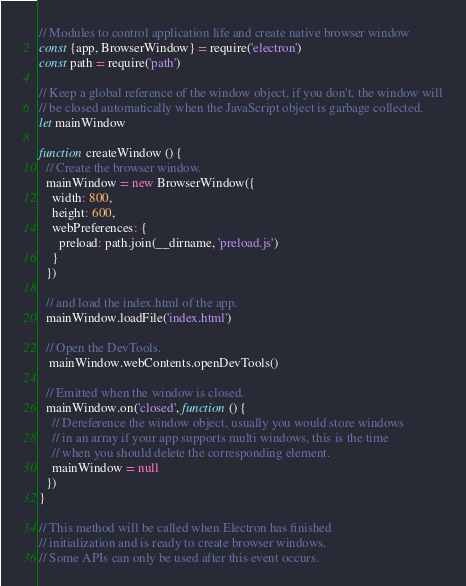<code> <loc_0><loc_0><loc_500><loc_500><_JavaScript_>// Modules to control application life and create native browser window
const {app, BrowserWindow} = require('electron')
const path = require('path')

// Keep a global reference of the window object, if you don't, the window will
// be closed automatically when the JavaScript object is garbage collected.
let mainWindow

function createWindow () {
  // Create the browser window.
  mainWindow = new BrowserWindow({
    width: 800,
    height: 600,
    webPreferences: {
      preload: path.join(__dirname, 'preload.js')
    }
  })

  // and load the index.html of the app.
  mainWindow.loadFile('index.html')

  // Open the DevTools.
   mainWindow.webContents.openDevTools()

  // Emitted when the window is closed.
  mainWindow.on('closed', function () {
    // Dereference the window object, usually you would store windows
    // in an array if your app supports multi windows, this is the time
    // when you should delete the corresponding element.
    mainWindow = null
  })
}

// This method will be called when Electron has finished
// initialization and is ready to create browser windows.
// Some APIs can only be used after this event occurs.</code> 